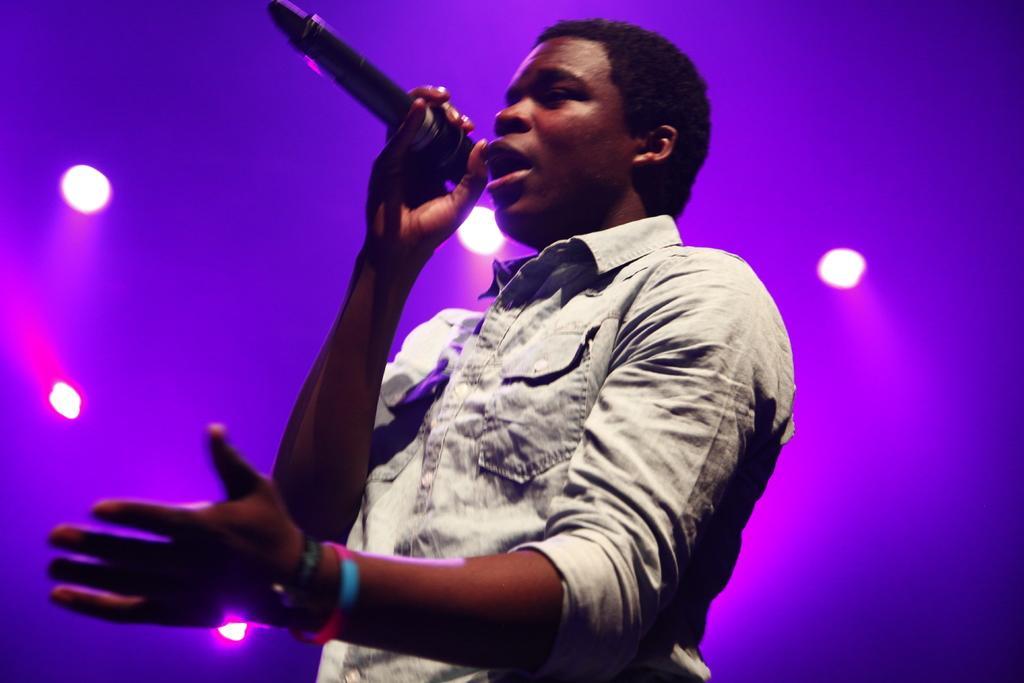Describe this image in one or two sentences. In this image we can see a man standing and holding a mic. In the background there are lights. 